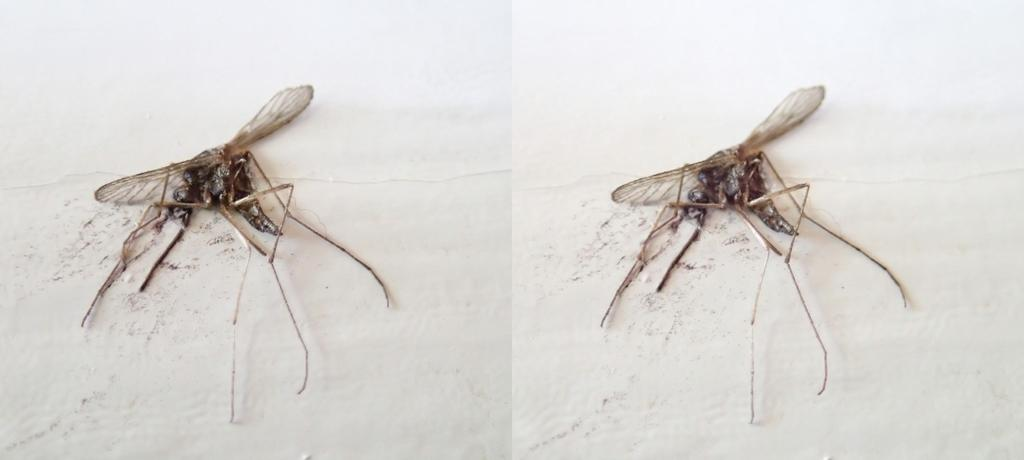How many frames are present in the image? There are two frames in the image. What is depicted in each frame? There is a dead mosquito in each frame. Who is the creator of the advertisement shown in the image? There is no advertisement present in the image, only two frames with dead mosquitoes. 